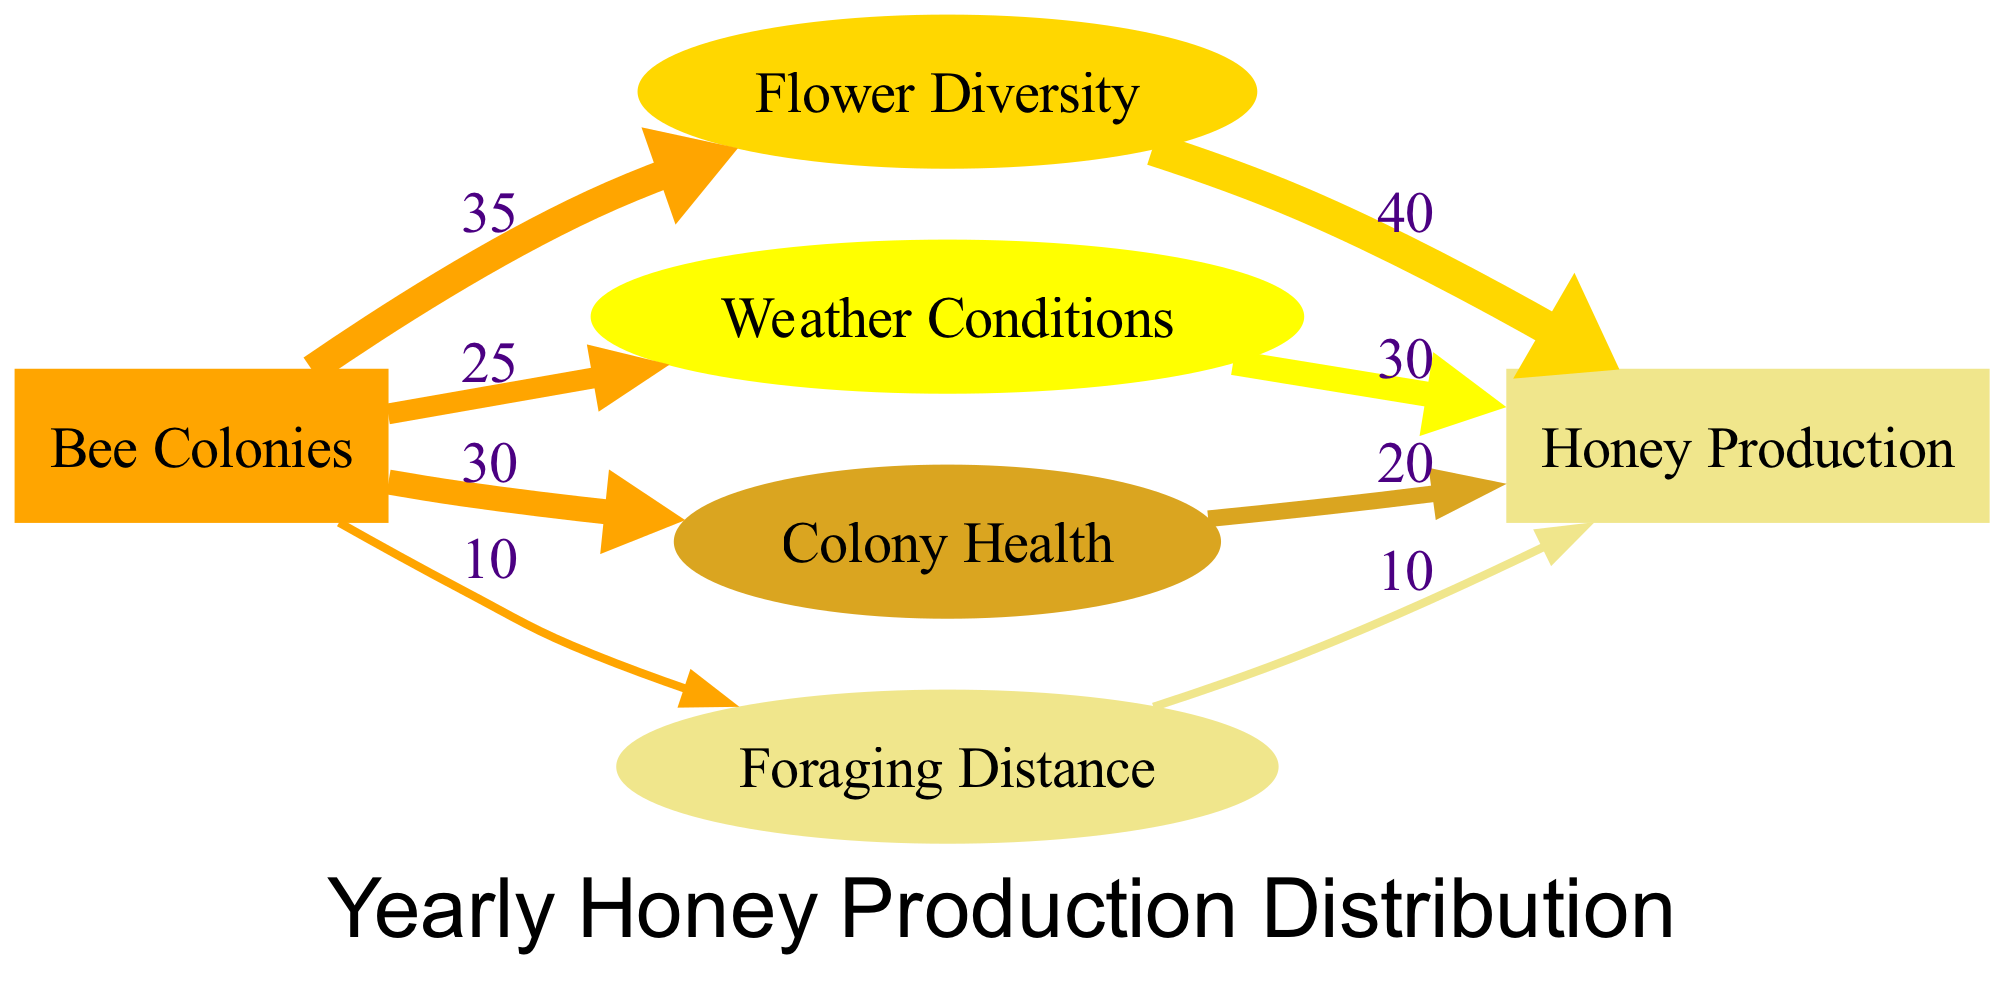What is the total value of Honey Production? To find the total value for Honey Production, we can sum the values of the links connecting to Honey Production. The values are 40 (from Flower Diversity) + 30 (from Weather Conditions) + 20 (from Colony Health) + 10 (from Foraging Distance), which equals 100.
Answer: 100 What factor contributes the most to Honey Production? The factor that contributes the most to Honey Production is Flower Diversity, which has a value of 40. This is determined by locating the link from Flower Diversity to Honey Production, which has the highest value compared to the other linking factors.
Answer: Flower Diversity How many different factors influence Honey Production? There are four factors influencing Honey Production: Flower Diversity, Weather Conditions, Colony Health, and Foraging Distance, as represented by the nodes linked to Honey Production.
Answer: 4 What is the value of the link between Colony Health and Honey Production? The value of the link connecting Colony Health to Honey Production is 20. This can be found by looking for the direct link that connects these two nodes in the diagram.
Answer: 20 Which factor has the lowest contribution to Honey Production? The factor that has the lowest contribution to Honey Production is Foraging Distance, with a value of 10. This is determined by comparing the values of all the influencing factors.
Answer: Foraging Distance What is the total value of links coming from Bee Colonies? The total value of links coming from Bee Colonies is 100. This is calculated by summing up the values of all links: 35 (to Flower Diversity) + 25 (to Weather Conditions) + 30 (to Colony Health) + 10 (to Foraging Distance) = 100.
Answer: 100 Which factor has the second highest impact on Honey Production? The factor with the second highest impact on Honey Production is Weather Conditions, with a value of 30. This is determined by comparing the values of the factors linked to Honey Production.
Answer: Weather Conditions How many nodes are displayed in the diagram? There are five nodes displayed in the diagram: Bee Colonies, Flower Diversity, Weather Conditions, Colony Health, and Foraging Distance.
Answer: 5 What percentage of total Honey Production does Colony Health represent? Colony Health represents 20% of the total Honey Production, calculated as (20/100)*100%, where 100 is the total Honey Production value.
Answer: 20% 